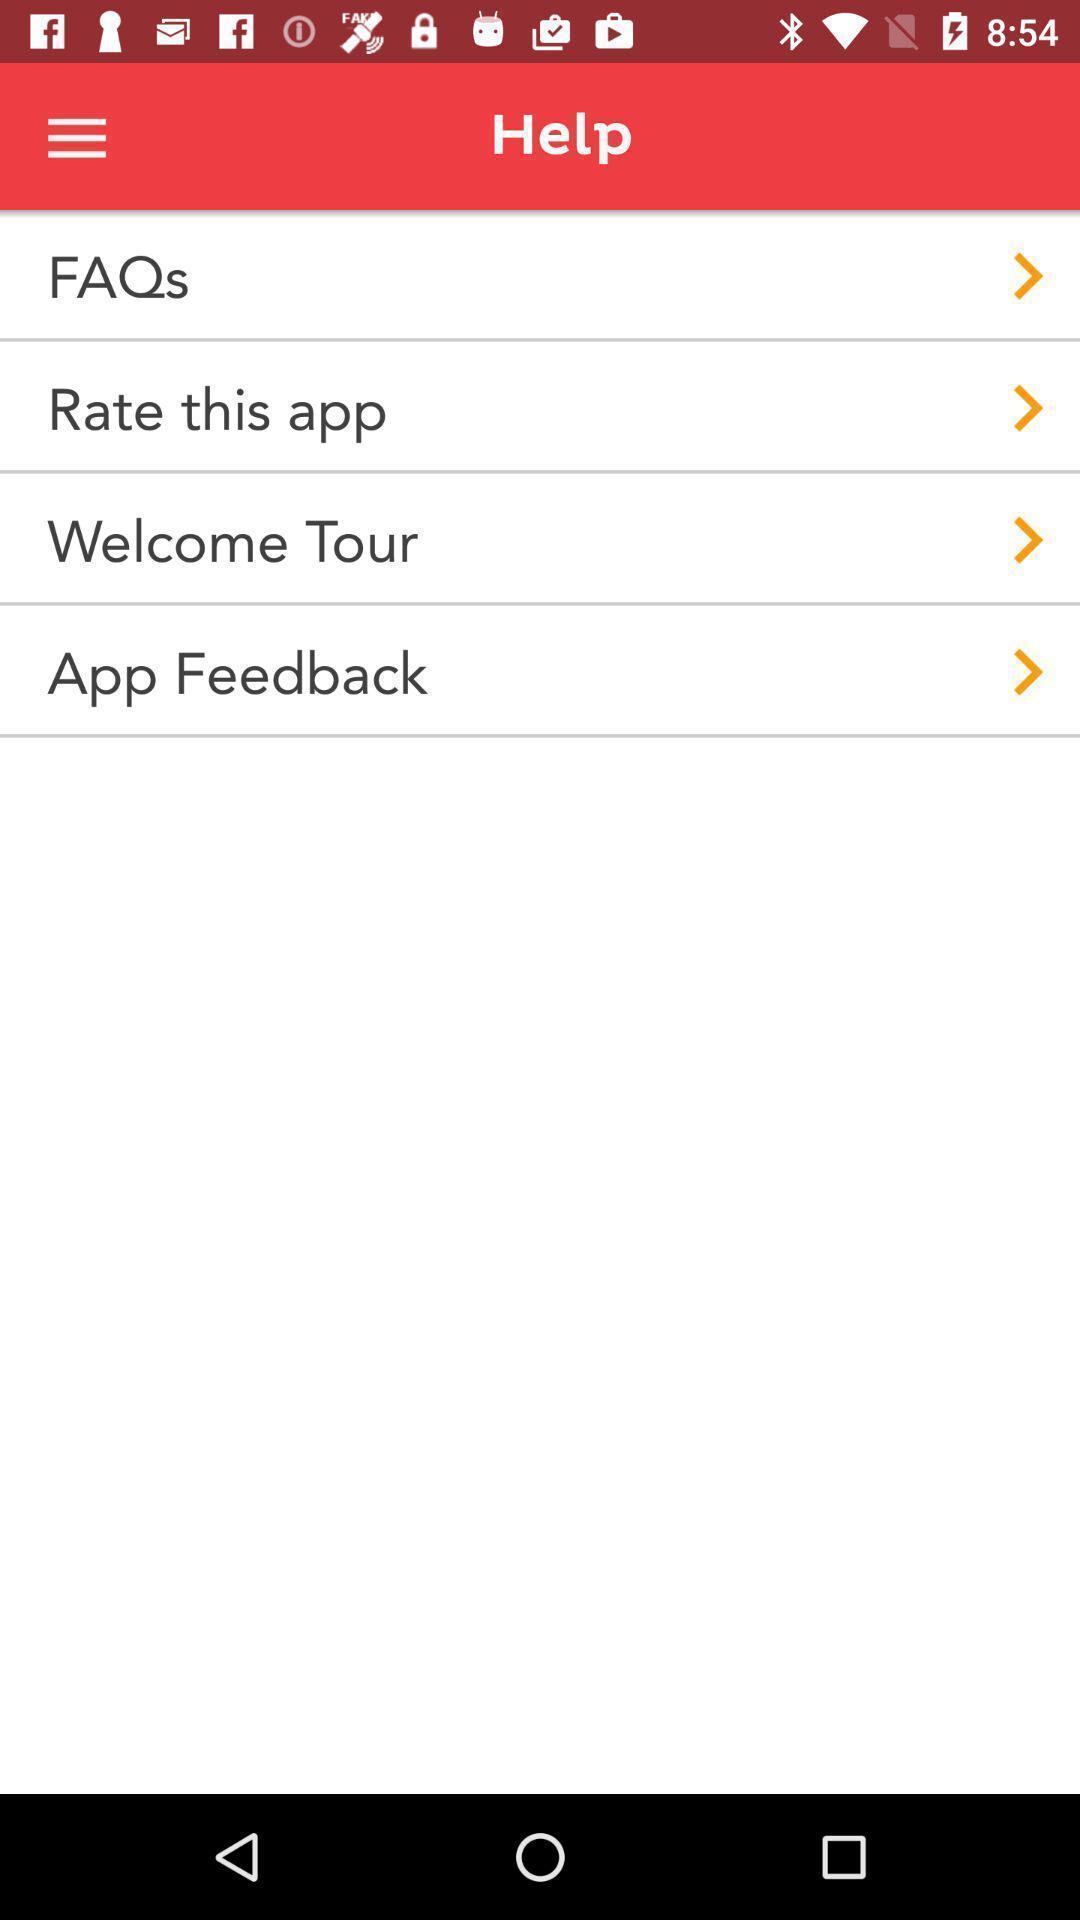What details can you identify in this image? Screen displaying multiple help options. 